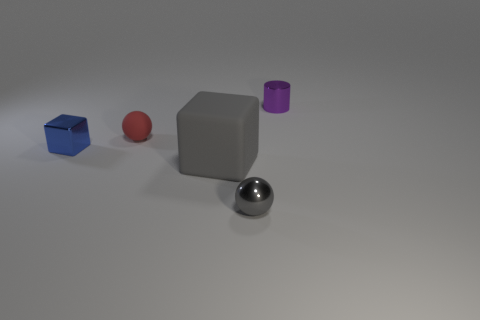There is a thing that is the same color as the large matte block; what is its shape?
Provide a succinct answer. Sphere. How many small metal objects have the same shape as the gray matte thing?
Your response must be concise. 1. There is a red object; what shape is it?
Give a very brief answer. Sphere. Are there the same number of shiny blocks behind the small matte sphere and big green rubber cylinders?
Provide a short and direct response. Yes. Are there any other things that are made of the same material as the small red sphere?
Provide a short and direct response. Yes. Are the sphere that is behind the small cube and the blue thing made of the same material?
Make the answer very short. No. Are there fewer tiny gray metal things that are behind the tiny purple metal thing than blue metallic blocks?
Offer a very short reply. Yes. How many matte objects are either large red cubes or big gray cubes?
Offer a terse response. 1. Do the rubber block and the metallic sphere have the same color?
Offer a terse response. Yes. Is there anything else that has the same color as the small matte sphere?
Offer a terse response. No. 